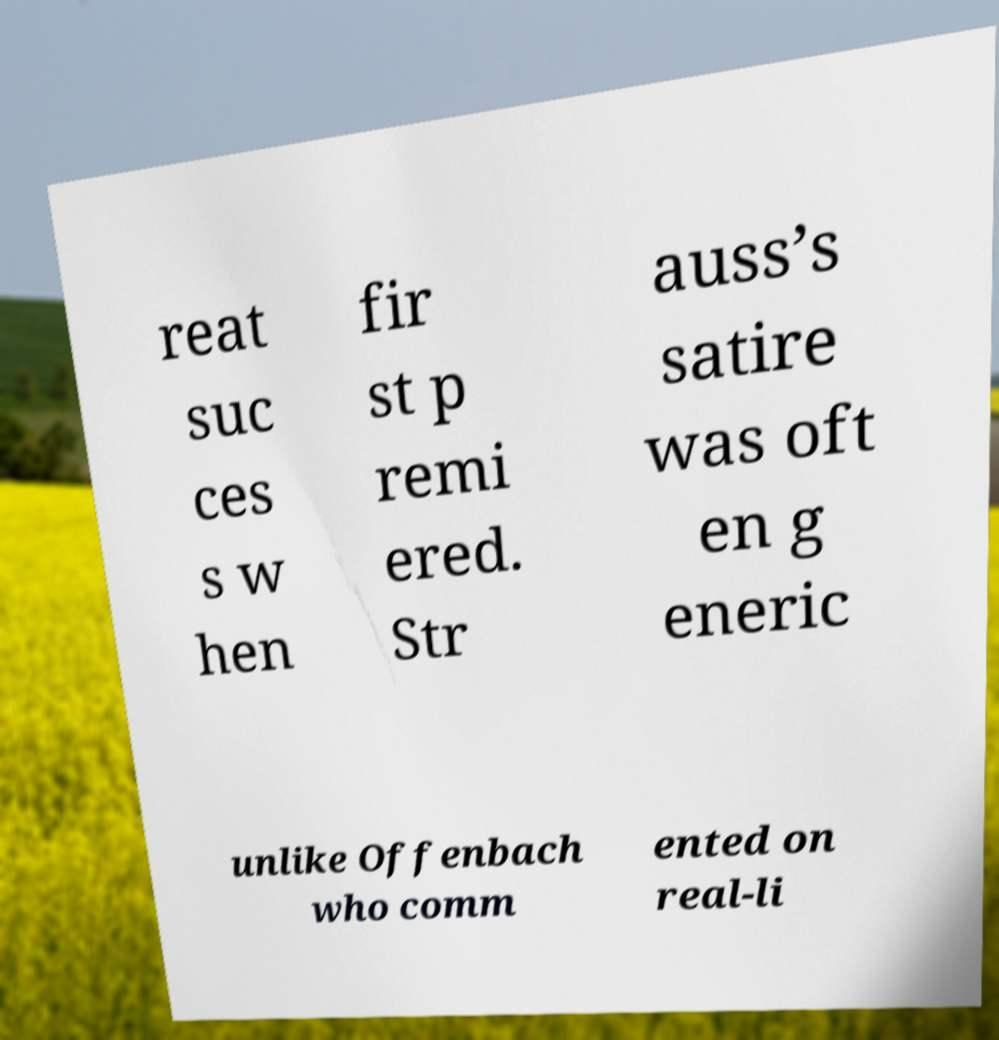Can you read and provide the text displayed in the image?This photo seems to have some interesting text. Can you extract and type it out for me? reat suc ces s w hen fir st p remi ered. Str auss’s satire was oft en g eneric unlike Offenbach who comm ented on real-li 